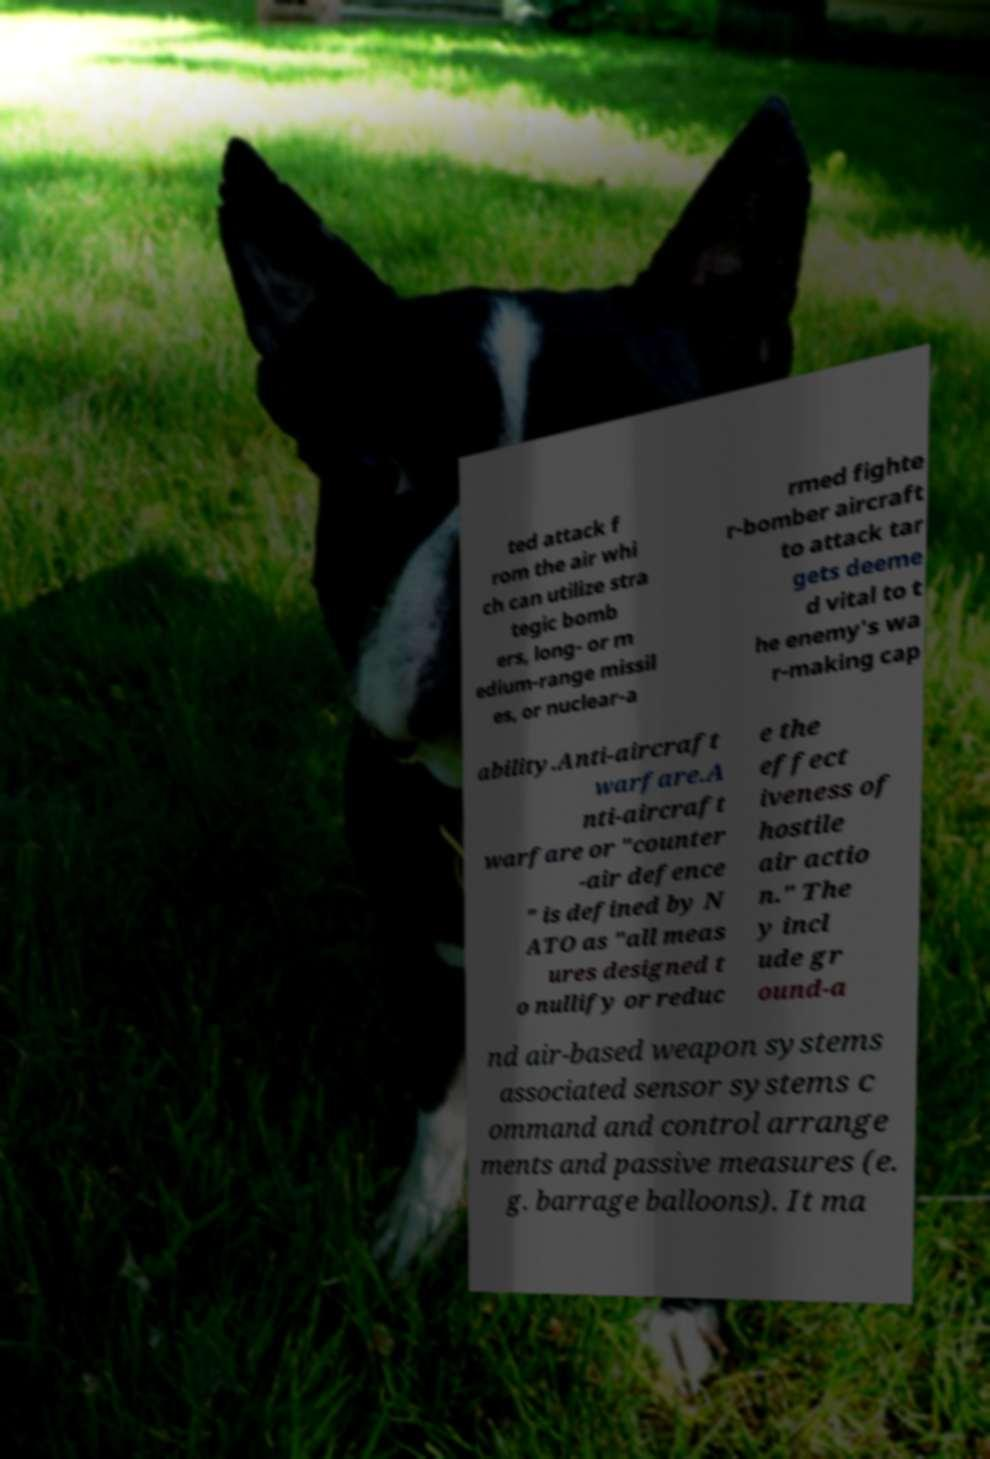Could you extract and type out the text from this image? ted attack f rom the air whi ch can utilize stra tegic bomb ers, long- or m edium-range missil es, or nuclear-a rmed fighte r-bomber aircraft to attack tar gets deeme d vital to t he enemy's wa r-making cap ability.Anti-aircraft warfare.A nti-aircraft warfare or "counter -air defence " is defined by N ATO as "all meas ures designed t o nullify or reduc e the effect iveness of hostile air actio n." The y incl ude gr ound-a nd air-based weapon systems associated sensor systems c ommand and control arrange ments and passive measures (e. g. barrage balloons). It ma 